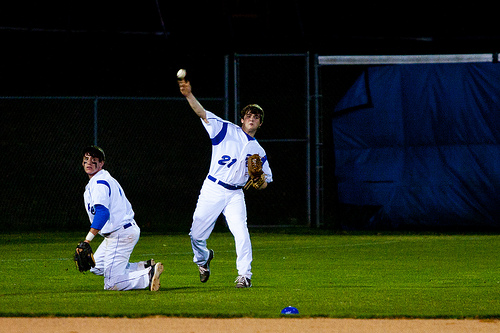How many players are in the picture? 2 